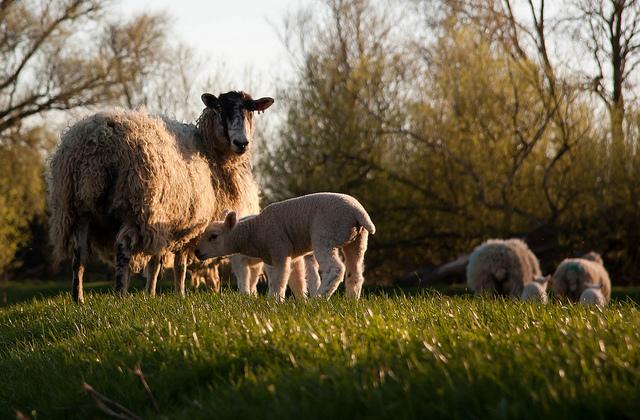How many lambs in this picture?
Give a very brief answer. 4. How many animals are in this photo?
Quick response, please. 6. What animals are these?
Answer briefly. Sheep. What animal is this?
Short answer required. Sheep. What is the baby lamb doing?
Short answer required. Nursing. What time of day is it?
Short answer required. Morning. Are the animals white?
Quick response, please. Yes. What color is the grass?
Give a very brief answer. Green. 